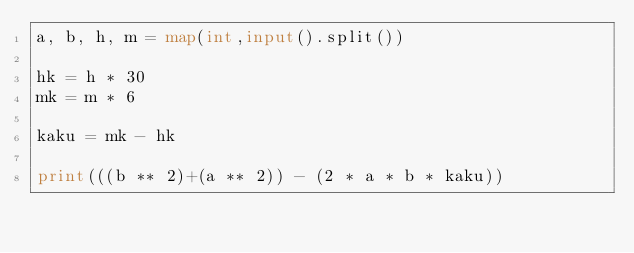Convert code to text. <code><loc_0><loc_0><loc_500><loc_500><_Python_>a, b, h, m = map(int,input().split())

hk = h * 30
mk = m * 6

kaku = mk - hk

print(((b ** 2)+(a ** 2)) - (2 * a * b * kaku))</code> 